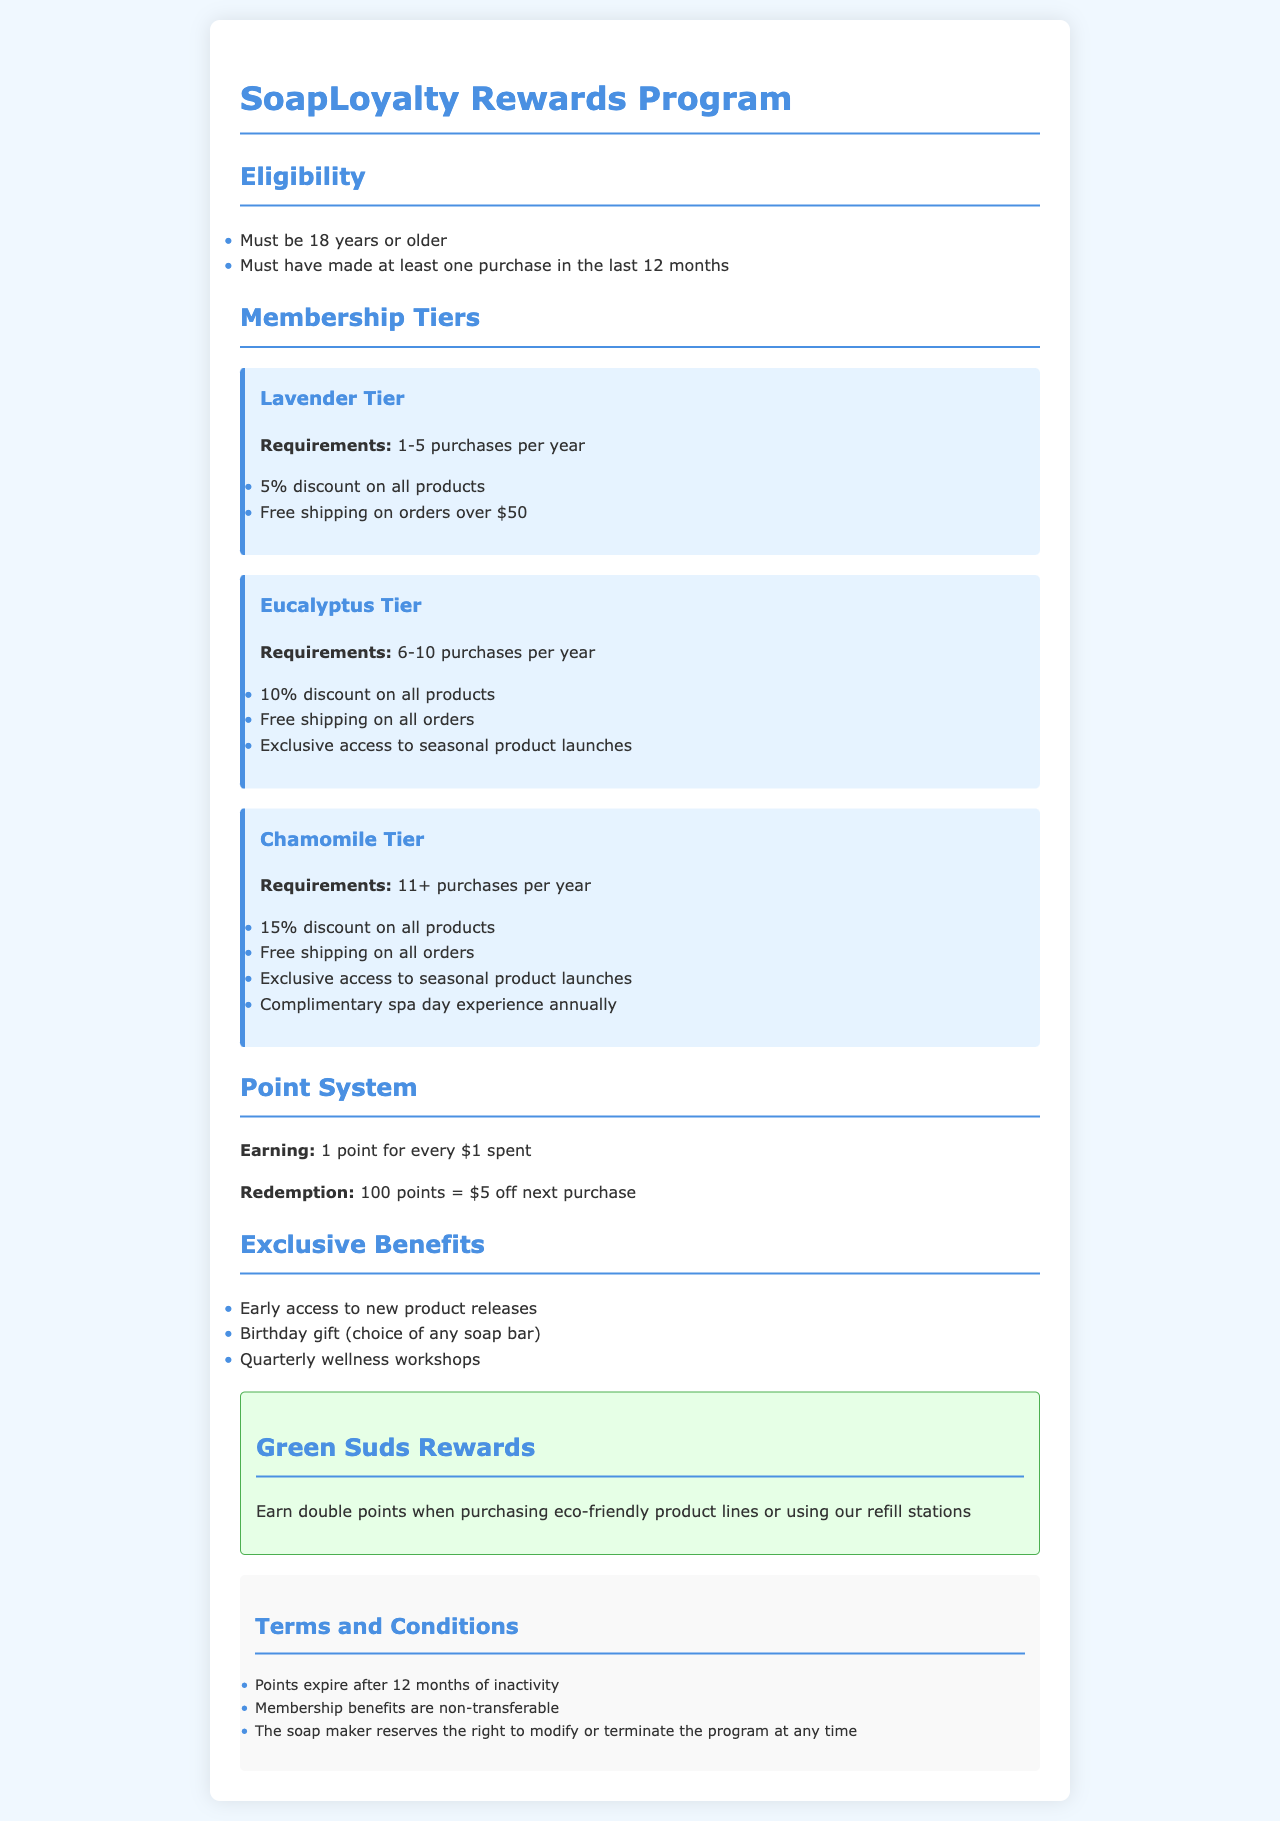What is the minimum age to join the program? Eligibility states that participants must be 18 years or older.
Answer: 18 years What is the requirement for the Lavender Tier? The document specifies that the Lavender Tier requires 1-5 purchases per year.
Answer: 1-5 purchases per year What discount do members in the Chamomile Tier receive? The Chamomile Tier offers a 15% discount on all products.
Answer: 15% How many points do you earn for every dollar spent? The point system indicates that you earn 1 point for every $1 spent.
Answer: 1 point What is required for free shipping in the Lavender Tier? Free shipping in the Lavender Tier applies to orders over $50.
Answer: Orders over $50 What is the annual benefit of the Chamomile Tier? Members in the Chamomile Tier receive a complimentary spa day experience annually.
Answer: Complimentary spa day experience How long do points last without activity? The document states that points expire after 12 months of inactivity.
Answer: 12 months What is the redemption value of 100 points? The redemption policy mentions that 100 points equal $5 off the next purchase.
Answer: $5 off 